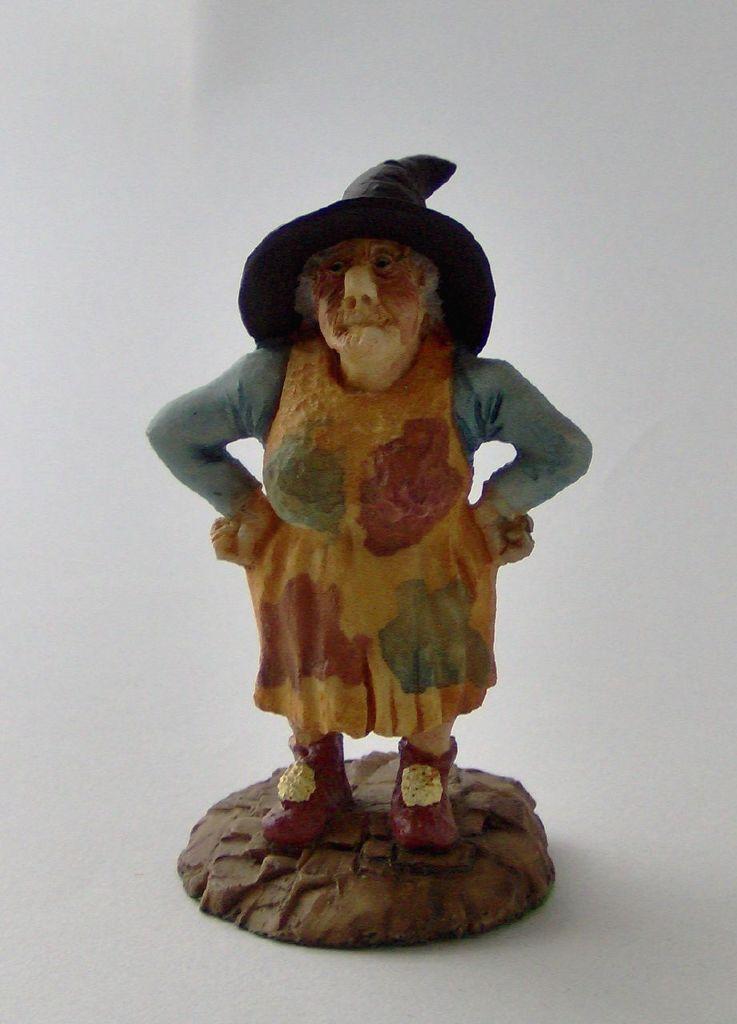Can you describe this image briefly? In this image there is a small statue in the middle. In the background it is white color. 